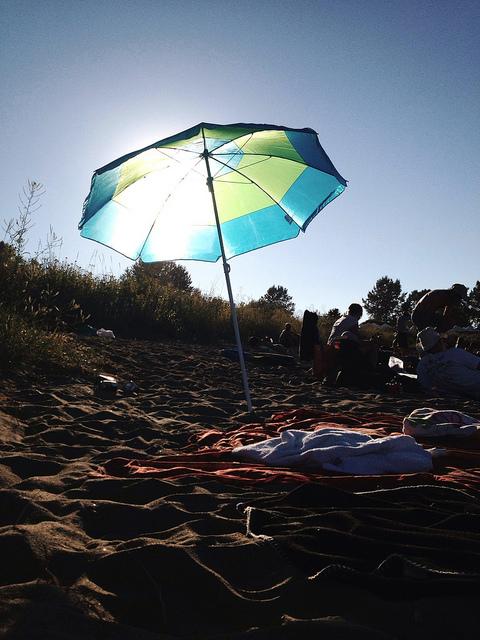What color is the umbrella?
Give a very brief answer. Blue and green. Is there any sand close by the water?
Quick response, please. Yes. How many beach towels are laying on the sand?
Be succinct. 2. What color is the blanket in front of the umbrella?
Keep it brief. Blue. What is blocking the sun?
Be succinct. Umbrella. Was the photo taken near a body of water?
Short answer required. Yes. 